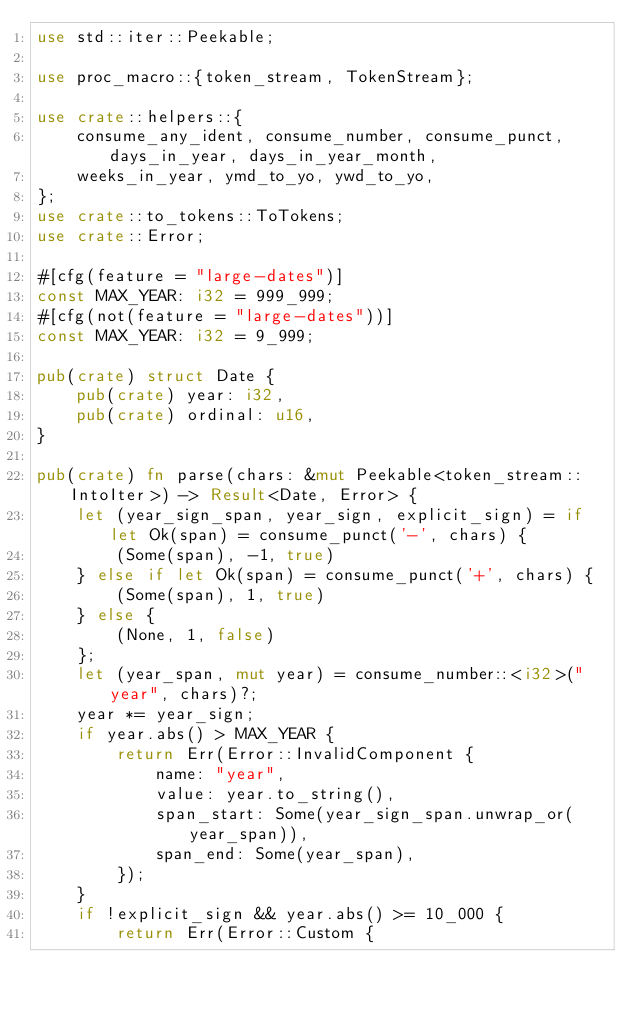<code> <loc_0><loc_0><loc_500><loc_500><_Rust_>use std::iter::Peekable;

use proc_macro::{token_stream, TokenStream};

use crate::helpers::{
    consume_any_ident, consume_number, consume_punct, days_in_year, days_in_year_month,
    weeks_in_year, ymd_to_yo, ywd_to_yo,
};
use crate::to_tokens::ToTokens;
use crate::Error;

#[cfg(feature = "large-dates")]
const MAX_YEAR: i32 = 999_999;
#[cfg(not(feature = "large-dates"))]
const MAX_YEAR: i32 = 9_999;

pub(crate) struct Date {
    pub(crate) year: i32,
    pub(crate) ordinal: u16,
}

pub(crate) fn parse(chars: &mut Peekable<token_stream::IntoIter>) -> Result<Date, Error> {
    let (year_sign_span, year_sign, explicit_sign) = if let Ok(span) = consume_punct('-', chars) {
        (Some(span), -1, true)
    } else if let Ok(span) = consume_punct('+', chars) {
        (Some(span), 1, true)
    } else {
        (None, 1, false)
    };
    let (year_span, mut year) = consume_number::<i32>("year", chars)?;
    year *= year_sign;
    if year.abs() > MAX_YEAR {
        return Err(Error::InvalidComponent {
            name: "year",
            value: year.to_string(),
            span_start: Some(year_sign_span.unwrap_or(year_span)),
            span_end: Some(year_span),
        });
    }
    if !explicit_sign && year.abs() >= 10_000 {
        return Err(Error::Custom {</code> 